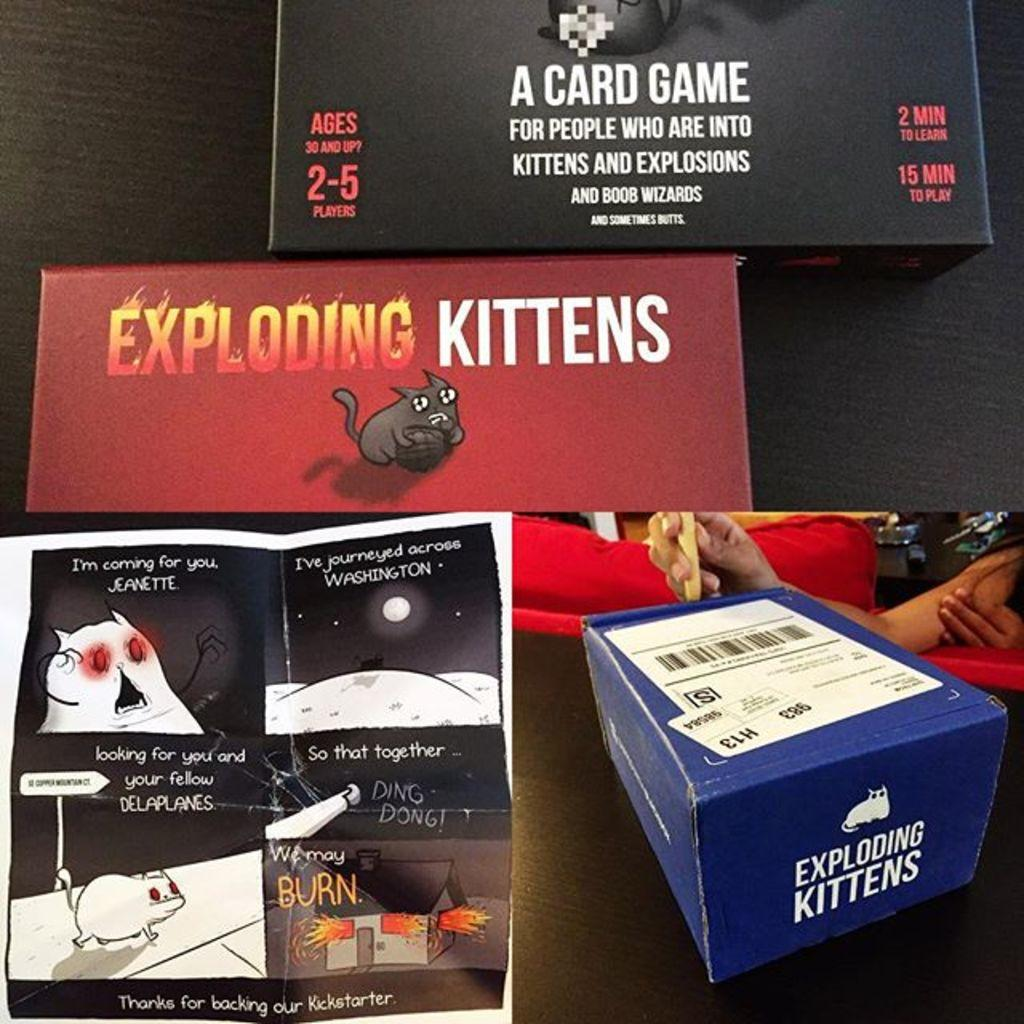Provide a one-sentence caption for the provided image. Blue box that says Exploding Kittens next to a manual. 